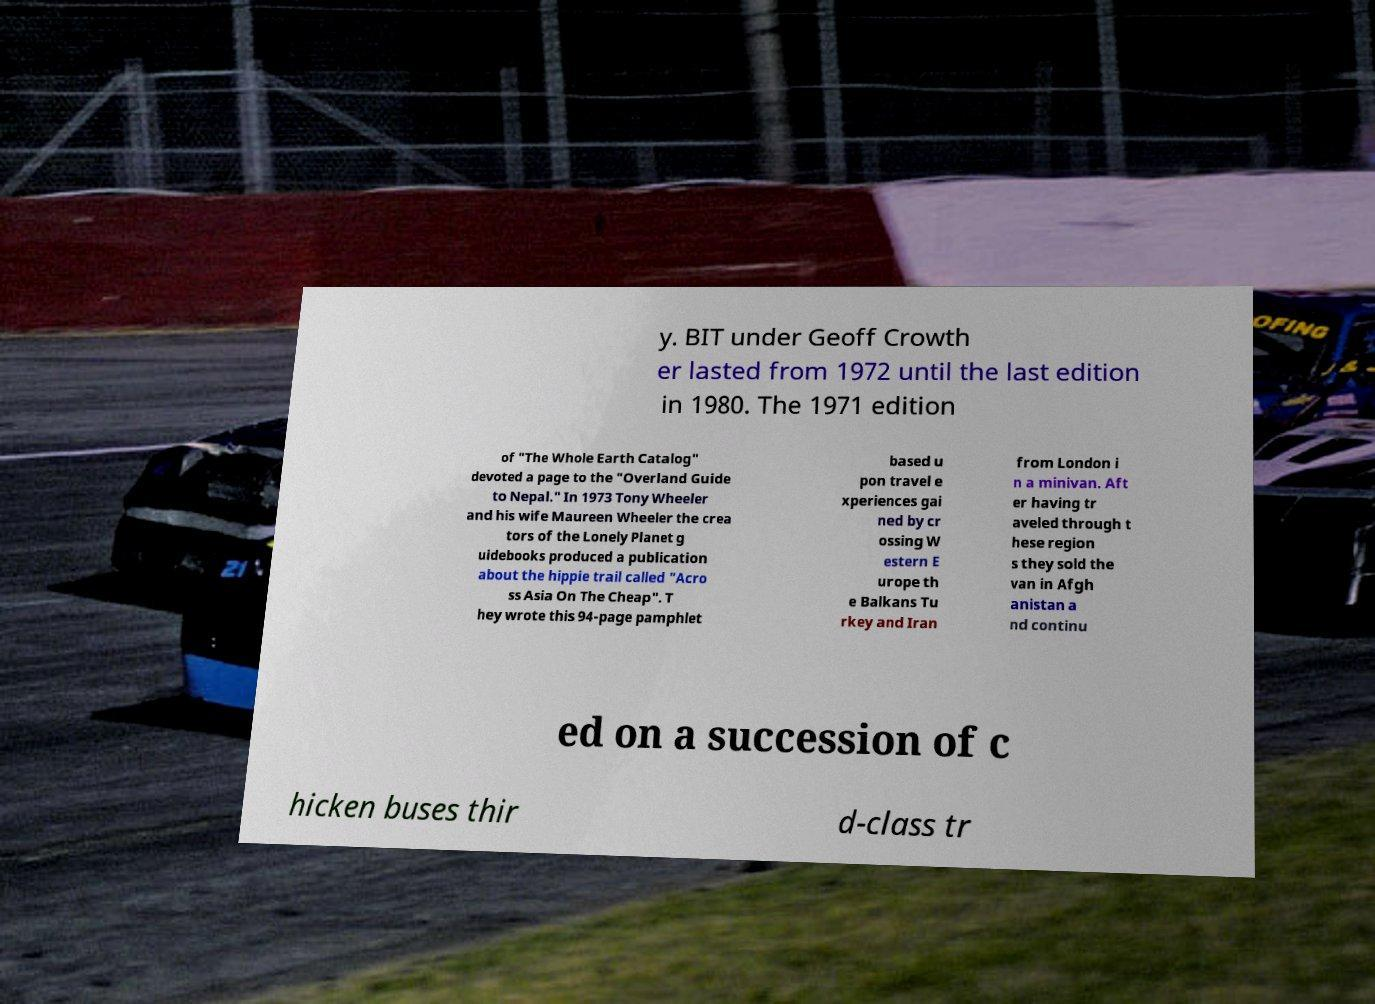What messages or text are displayed in this image? I need them in a readable, typed format. y. BIT under Geoff Crowth er lasted from 1972 until the last edition in 1980. The 1971 edition of "The Whole Earth Catalog" devoted a page to the "Overland Guide to Nepal." In 1973 Tony Wheeler and his wife Maureen Wheeler the crea tors of the Lonely Planet g uidebooks produced a publication about the hippie trail called "Acro ss Asia On The Cheap". T hey wrote this 94-page pamphlet based u pon travel e xperiences gai ned by cr ossing W estern E urope th e Balkans Tu rkey and Iran from London i n a minivan. Aft er having tr aveled through t hese region s they sold the van in Afgh anistan a nd continu ed on a succession of c hicken buses thir d-class tr 